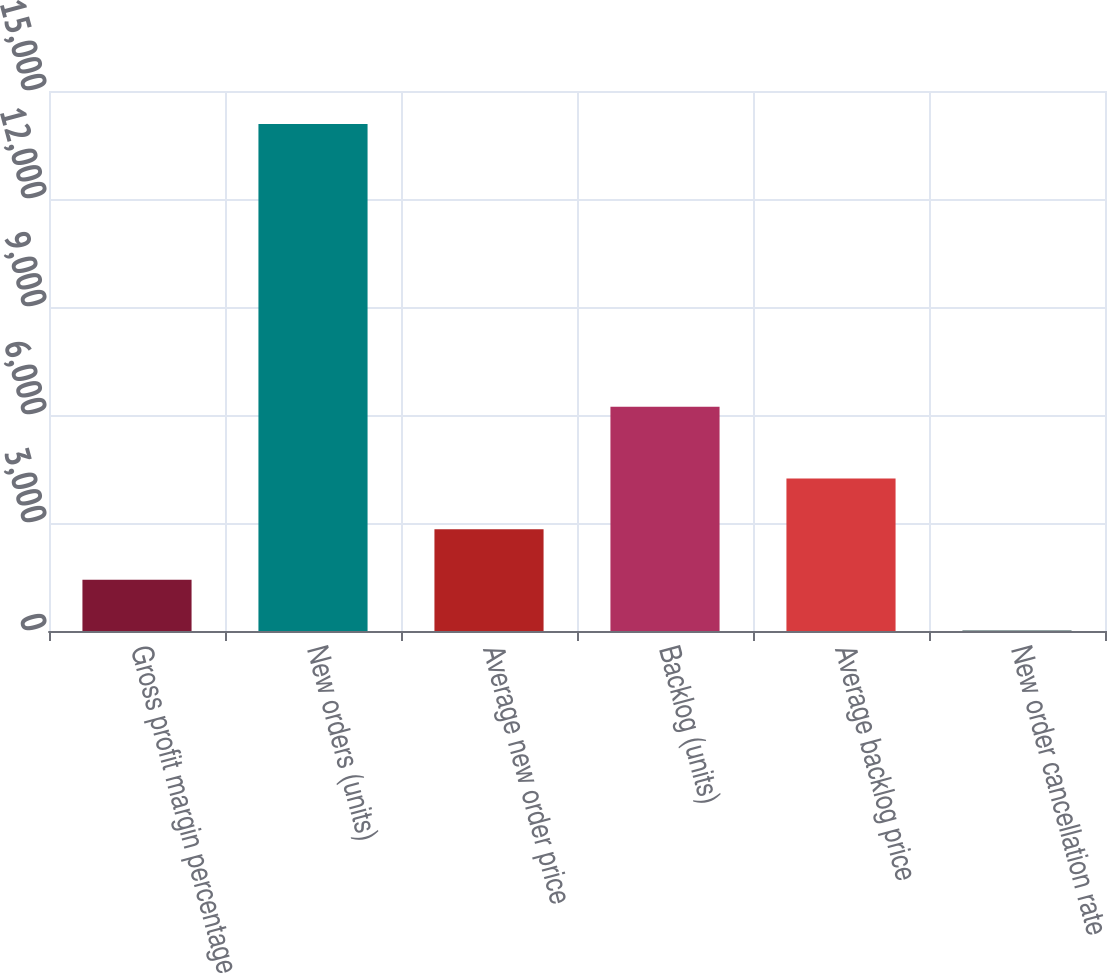Convert chart to OTSL. <chart><loc_0><loc_0><loc_500><loc_500><bar_chart><fcel>Gross profit margin percentage<fcel>New orders (units)<fcel>Average new order price<fcel>Backlog (units)<fcel>Average backlog price<fcel>New order cancellation rate<nl><fcel>1421.05<fcel>14080<fcel>2827.6<fcel>6229<fcel>4234.15<fcel>14.5<nl></chart> 